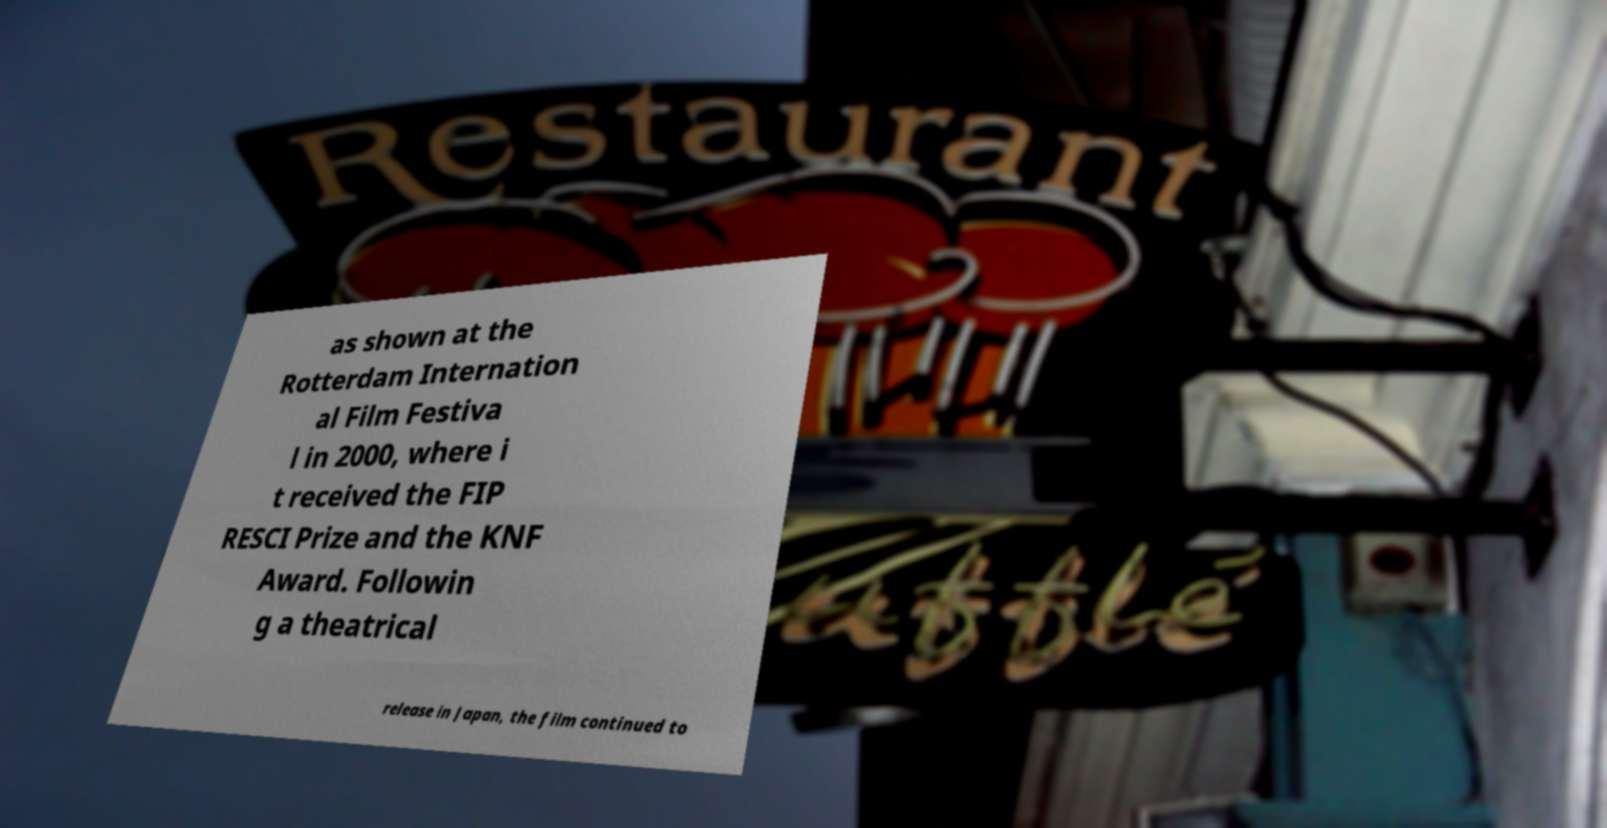Please identify and transcribe the text found in this image. as shown at the Rotterdam Internation al Film Festiva l in 2000, where i t received the FIP RESCI Prize and the KNF Award. Followin g a theatrical release in Japan, the film continued to 